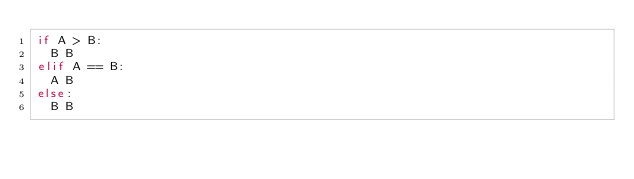<code> <loc_0><loc_0><loc_500><loc_500><_Python_>if A > B:
  B B
elif A == B:
  A B
else:
  B B</code> 